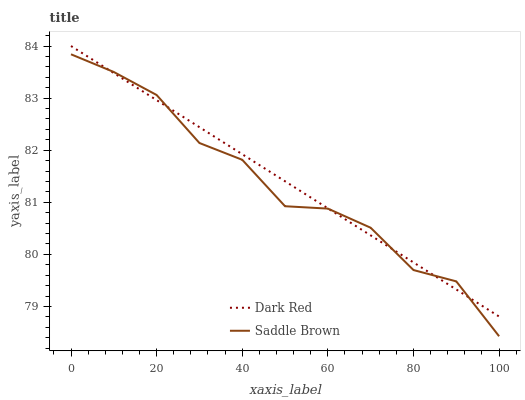Does Saddle Brown have the minimum area under the curve?
Answer yes or no. Yes. Does Dark Red have the maximum area under the curve?
Answer yes or no. Yes. Does Saddle Brown have the maximum area under the curve?
Answer yes or no. No. Is Dark Red the smoothest?
Answer yes or no. Yes. Is Saddle Brown the roughest?
Answer yes or no. Yes. Is Saddle Brown the smoothest?
Answer yes or no. No. Does Dark Red have the highest value?
Answer yes or no. Yes. Does Saddle Brown have the highest value?
Answer yes or no. No. Does Saddle Brown intersect Dark Red?
Answer yes or no. Yes. Is Saddle Brown less than Dark Red?
Answer yes or no. No. Is Saddle Brown greater than Dark Red?
Answer yes or no. No. 